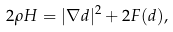Convert formula to latex. <formula><loc_0><loc_0><loc_500><loc_500>2 \rho H = | \nabla d | ^ { 2 } + 2 F ( d ) ,</formula> 